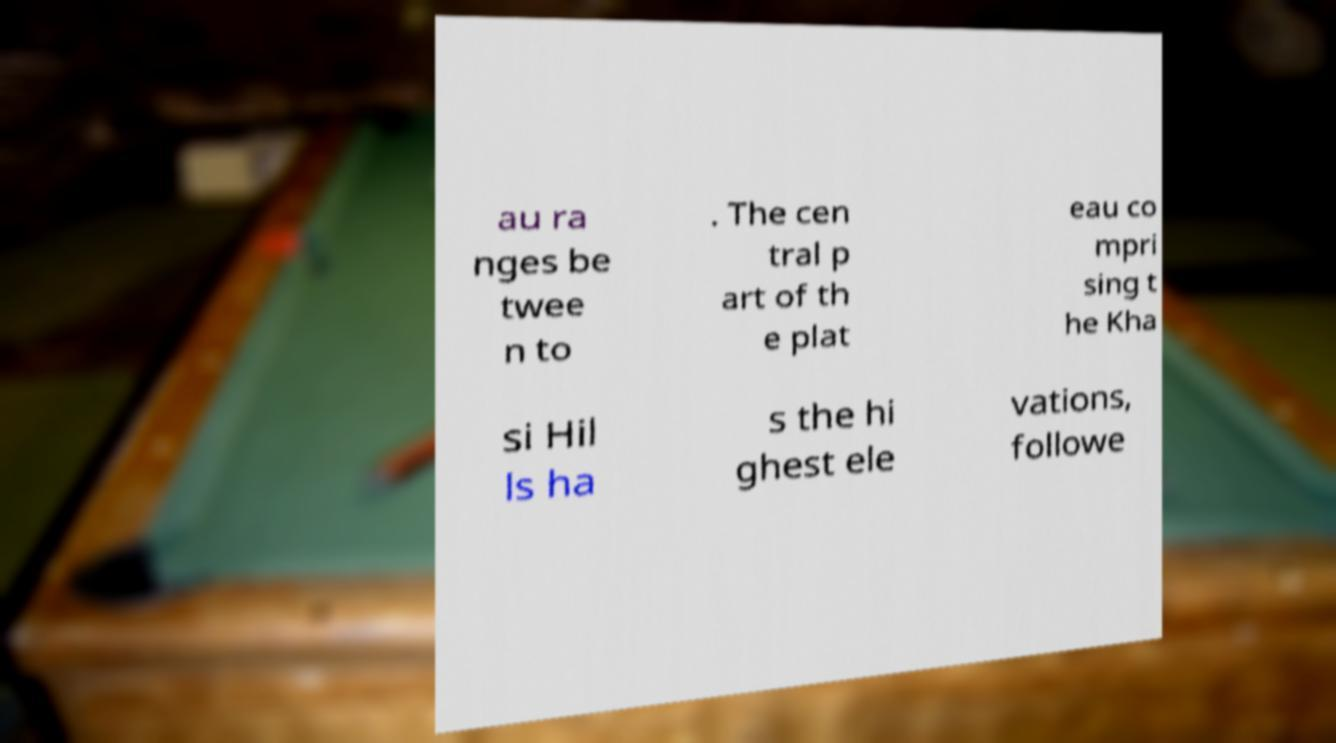Could you assist in decoding the text presented in this image and type it out clearly? au ra nges be twee n to . The cen tral p art of th e plat eau co mpri sing t he Kha si Hil ls ha s the hi ghest ele vations, followe 